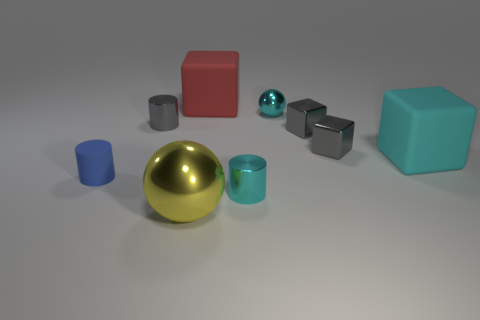There is a small gray shiny thing that is on the left side of the big yellow metallic thing; does it have the same shape as the red thing?
Provide a short and direct response. No. How many tiny gray things are to the right of the cyan cylinder to the left of the tiny cyan thing behind the cyan block?
Provide a short and direct response. 2. Is the number of red blocks in front of the big red matte object less than the number of metallic cylinders to the left of the small cyan cylinder?
Give a very brief answer. Yes. There is another rubber object that is the same shape as the cyan matte thing; what is its color?
Offer a terse response. Red. How big is the yellow metal ball?
Provide a succinct answer. Large. What number of other blocks have the same size as the cyan rubber block?
Provide a short and direct response. 1. Does the big metallic thing have the same color as the rubber cylinder?
Make the answer very short. No. Is the large yellow sphere in front of the red cube made of the same material as the cyan thing that is behind the large cyan rubber object?
Offer a very short reply. Yes. Is the number of cyan matte things greater than the number of cyan shiny things?
Provide a succinct answer. No. Is there anything else of the same color as the small sphere?
Provide a succinct answer. Yes. 